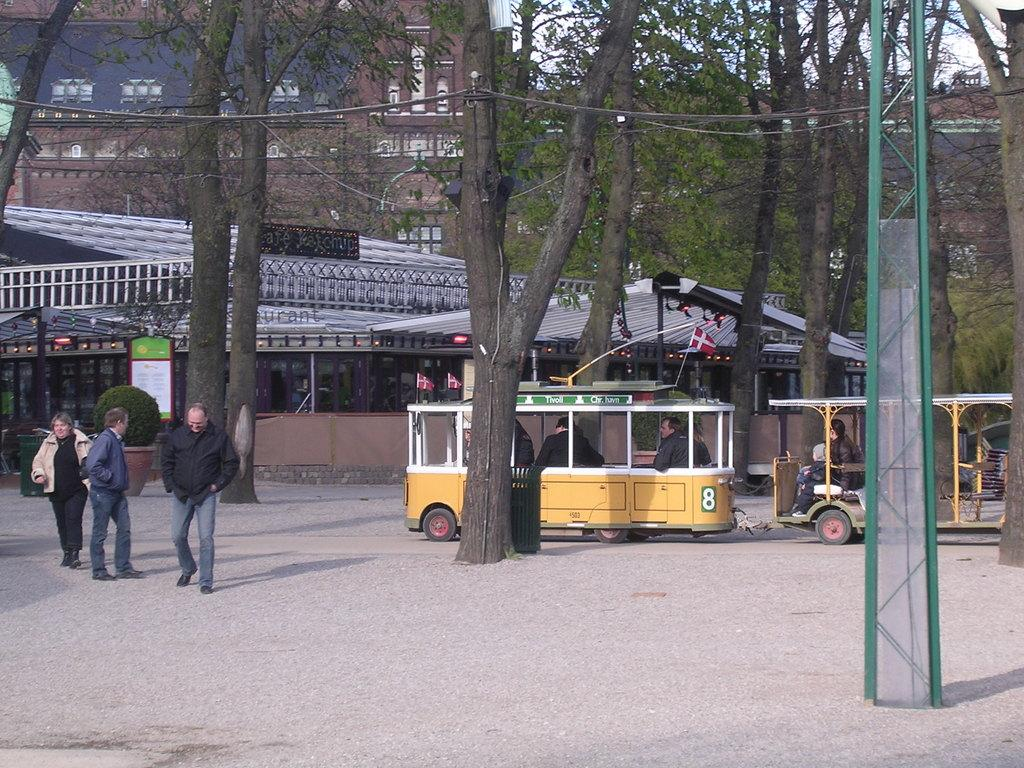Provide a one-sentence caption for the provided image. A yellow trolley that has the number 8 on it takes people though a park. 